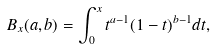<formula> <loc_0><loc_0><loc_500><loc_500>B _ { x } ( a , b ) = \int _ { 0 } ^ { x } t ^ { a - 1 } ( 1 - t ) ^ { b - 1 } d t ,</formula> 